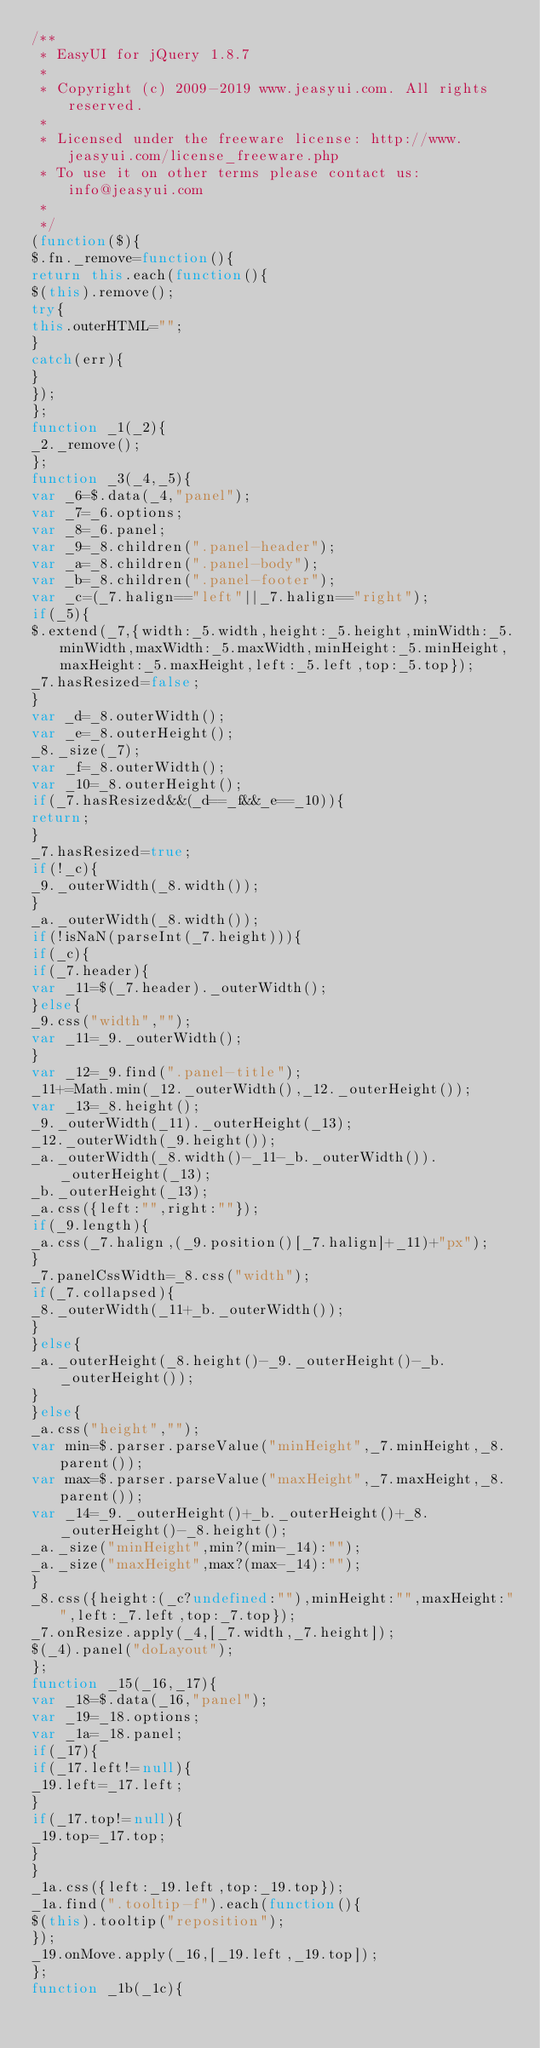Convert code to text. <code><loc_0><loc_0><loc_500><loc_500><_JavaScript_>/**
 * EasyUI for jQuery 1.8.7
 * 
 * Copyright (c) 2009-2019 www.jeasyui.com. All rights reserved.
 *
 * Licensed under the freeware license: http://www.jeasyui.com/license_freeware.php
 * To use it on other terms please contact us: info@jeasyui.com
 *
 */
(function($){
$.fn._remove=function(){
return this.each(function(){
$(this).remove();
try{
this.outerHTML="";
}
catch(err){
}
});
};
function _1(_2){
_2._remove();
};
function _3(_4,_5){
var _6=$.data(_4,"panel");
var _7=_6.options;
var _8=_6.panel;
var _9=_8.children(".panel-header");
var _a=_8.children(".panel-body");
var _b=_8.children(".panel-footer");
var _c=(_7.halign=="left"||_7.halign=="right");
if(_5){
$.extend(_7,{width:_5.width,height:_5.height,minWidth:_5.minWidth,maxWidth:_5.maxWidth,minHeight:_5.minHeight,maxHeight:_5.maxHeight,left:_5.left,top:_5.top});
_7.hasResized=false;
}
var _d=_8.outerWidth();
var _e=_8.outerHeight();
_8._size(_7);
var _f=_8.outerWidth();
var _10=_8.outerHeight();
if(_7.hasResized&&(_d==_f&&_e==_10)){
return;
}
_7.hasResized=true;
if(!_c){
_9._outerWidth(_8.width());
}
_a._outerWidth(_8.width());
if(!isNaN(parseInt(_7.height))){
if(_c){
if(_7.header){
var _11=$(_7.header)._outerWidth();
}else{
_9.css("width","");
var _11=_9._outerWidth();
}
var _12=_9.find(".panel-title");
_11+=Math.min(_12._outerWidth(),_12._outerHeight());
var _13=_8.height();
_9._outerWidth(_11)._outerHeight(_13);
_12._outerWidth(_9.height());
_a._outerWidth(_8.width()-_11-_b._outerWidth())._outerHeight(_13);
_b._outerHeight(_13);
_a.css({left:"",right:""});
if(_9.length){
_a.css(_7.halign,(_9.position()[_7.halign]+_11)+"px");
}
_7.panelCssWidth=_8.css("width");
if(_7.collapsed){
_8._outerWidth(_11+_b._outerWidth());
}
}else{
_a._outerHeight(_8.height()-_9._outerHeight()-_b._outerHeight());
}
}else{
_a.css("height","");
var min=$.parser.parseValue("minHeight",_7.minHeight,_8.parent());
var max=$.parser.parseValue("maxHeight",_7.maxHeight,_8.parent());
var _14=_9._outerHeight()+_b._outerHeight()+_8._outerHeight()-_8.height();
_a._size("minHeight",min?(min-_14):"");
_a._size("maxHeight",max?(max-_14):"");
}
_8.css({height:(_c?undefined:""),minHeight:"",maxHeight:"",left:_7.left,top:_7.top});
_7.onResize.apply(_4,[_7.width,_7.height]);
$(_4).panel("doLayout");
};
function _15(_16,_17){
var _18=$.data(_16,"panel");
var _19=_18.options;
var _1a=_18.panel;
if(_17){
if(_17.left!=null){
_19.left=_17.left;
}
if(_17.top!=null){
_19.top=_17.top;
}
}
_1a.css({left:_19.left,top:_19.top});
_1a.find(".tooltip-f").each(function(){
$(this).tooltip("reposition");
});
_19.onMove.apply(_16,[_19.left,_19.top]);
};
function _1b(_1c){</code> 